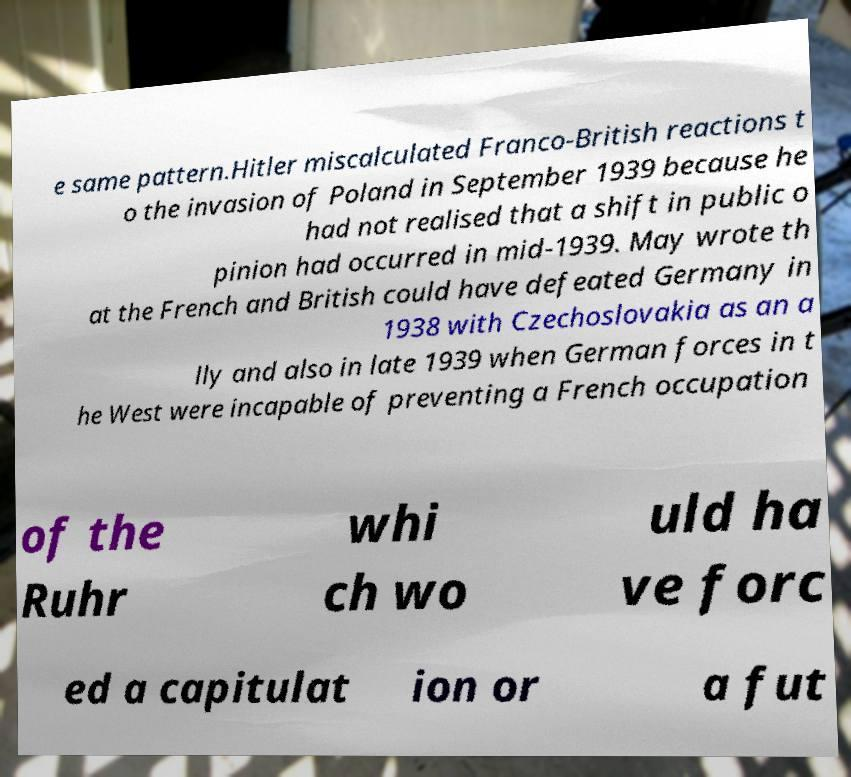Please read and relay the text visible in this image. What does it say? e same pattern.Hitler miscalculated Franco-British reactions t o the invasion of Poland in September 1939 because he had not realised that a shift in public o pinion had occurred in mid-1939. May wrote th at the French and British could have defeated Germany in 1938 with Czechoslovakia as an a lly and also in late 1939 when German forces in t he West were incapable of preventing a French occupation of the Ruhr whi ch wo uld ha ve forc ed a capitulat ion or a fut 